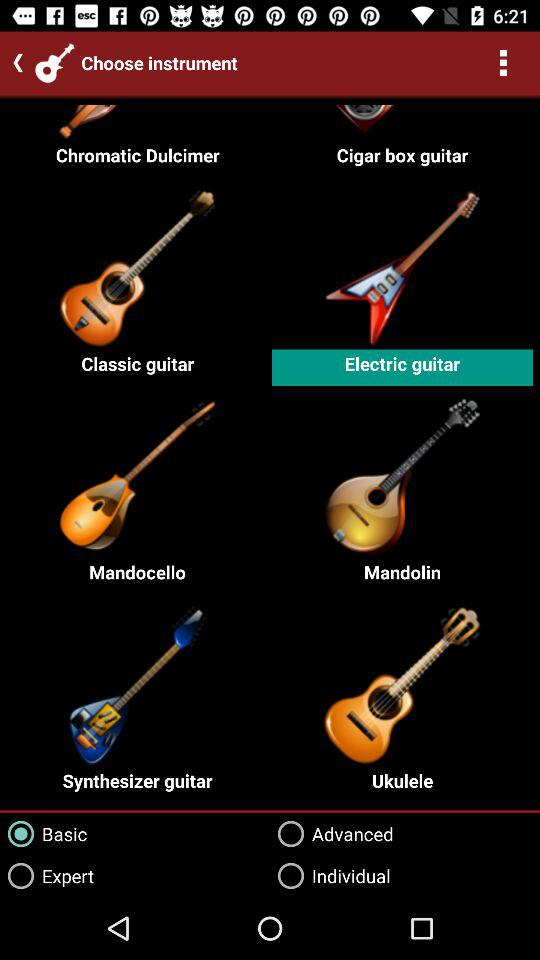What is the level of proficiency? The level of proficiency is "Basic". 